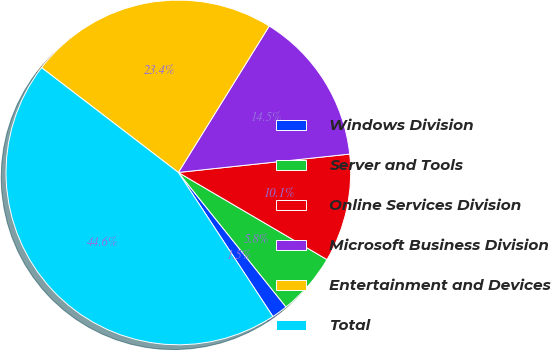Convert chart. <chart><loc_0><loc_0><loc_500><loc_500><pie_chart><fcel>Windows Division<fcel>Server and Tools<fcel>Online Services Division<fcel>Microsoft Business Division<fcel>Entertainment and Devices<fcel>Total<nl><fcel>1.5%<fcel>5.82%<fcel>10.14%<fcel>14.46%<fcel>23.44%<fcel>44.65%<nl></chart> 